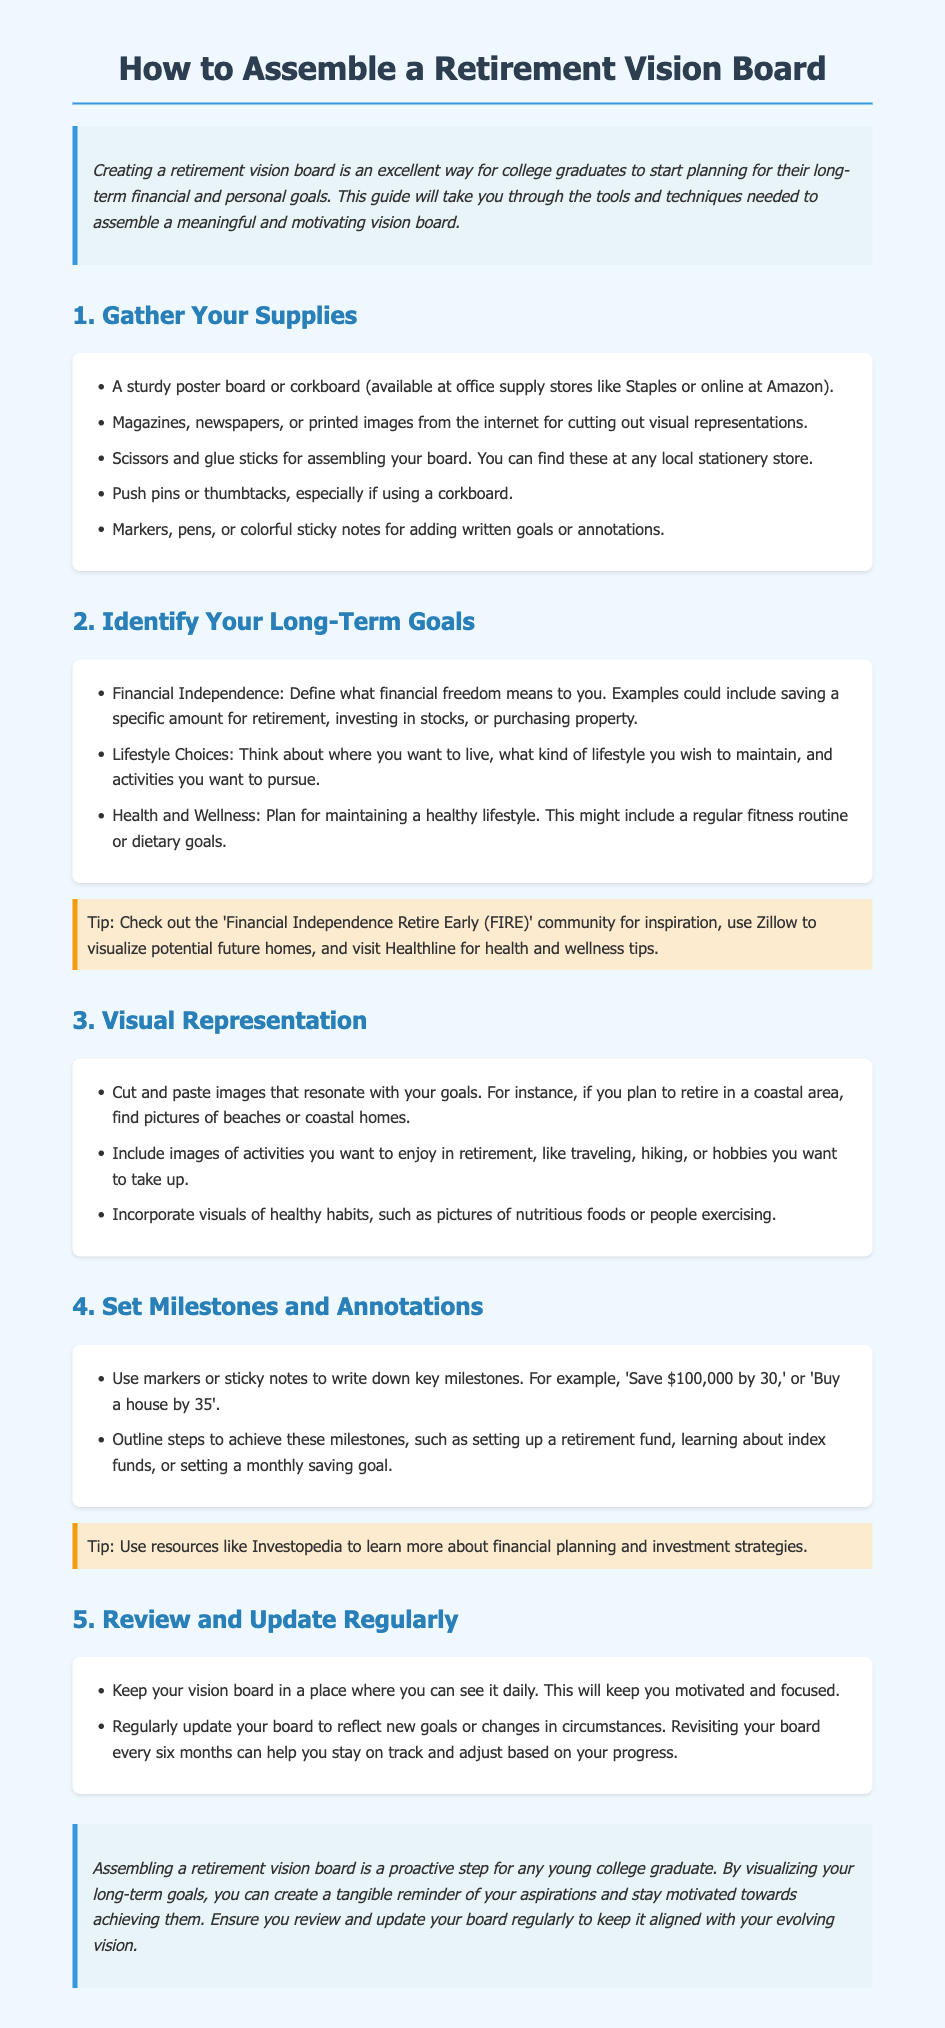what materials do I need for a retirement vision board? The materials needed for a retirement vision board include a sturdy poster board or corkboard, magazines, scissors, glue sticks, push pins or thumbtacks, and markers or pens.
Answer: poster board, magazines, scissors, glue sticks, push pins, markers what is one example of a long-term goal? The document provides examples of long-term goals, such as defining what financial freedom means.
Answer: financial independence which community is suggested for inspiration in setting financial goals? The document mentions a specific community to check out for inspiration regarding financial goals.
Answer: FIRE what is the purpose of reviewing and updating the vision board? The document states that regularly updating your board helps to reflect new goals or changes in circumstances.
Answer: stay on track how often should I revisit my vision board? The document recommends a frequency for revisiting the vision board to stay aligned with your goals.
Answer: every six months 